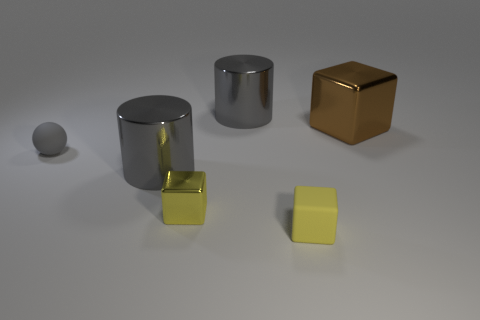Subtract all metallic blocks. How many blocks are left? 1 Add 2 blue cylinders. How many objects exist? 8 Subtract all yellow blocks. How many blocks are left? 1 Subtract 1 cubes. How many cubes are left? 2 Subtract all blue cylinders. How many yellow cubes are left? 2 Subtract all cylinders. How many objects are left? 4 Subtract all brown balls. Subtract all purple cylinders. How many balls are left? 1 Subtract all big gray cylinders. Subtract all gray metallic cylinders. How many objects are left? 2 Add 6 gray spheres. How many gray spheres are left? 7 Add 2 tiny shiny objects. How many tiny shiny objects exist? 3 